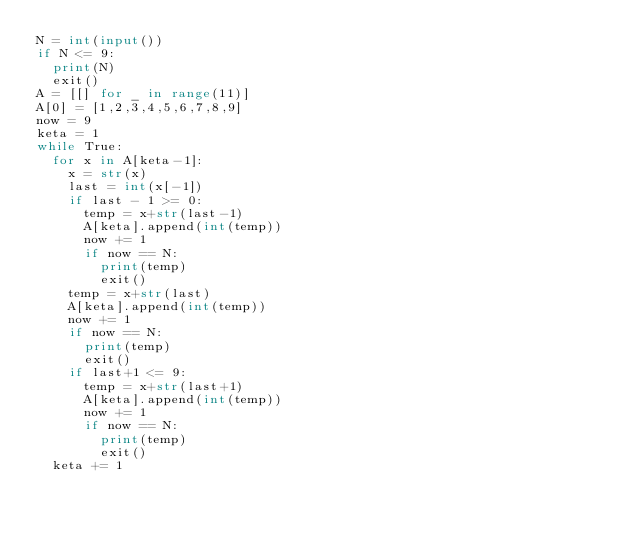<code> <loc_0><loc_0><loc_500><loc_500><_Python_>N = int(input())
if N <= 9:
  print(N)
  exit()
A = [[] for _ in range(11)]
A[0] = [1,2,3,4,5,6,7,8,9]
now = 9
keta = 1
while True:
  for x in A[keta-1]:
    x = str(x)
    last = int(x[-1])
    if last - 1 >= 0:
      temp = x+str(last-1)
      A[keta].append(int(temp))
      now += 1
      if now == N:
        print(temp)
        exit()
    temp = x+str(last)
    A[keta].append(int(temp))
    now += 1
    if now == N:
      print(temp)
      exit()
    if last+1 <= 9:
      temp = x+str(last+1)
      A[keta].append(int(temp))
      now += 1
      if now == N:
        print(temp)
        exit()
  keta += 1

</code> 